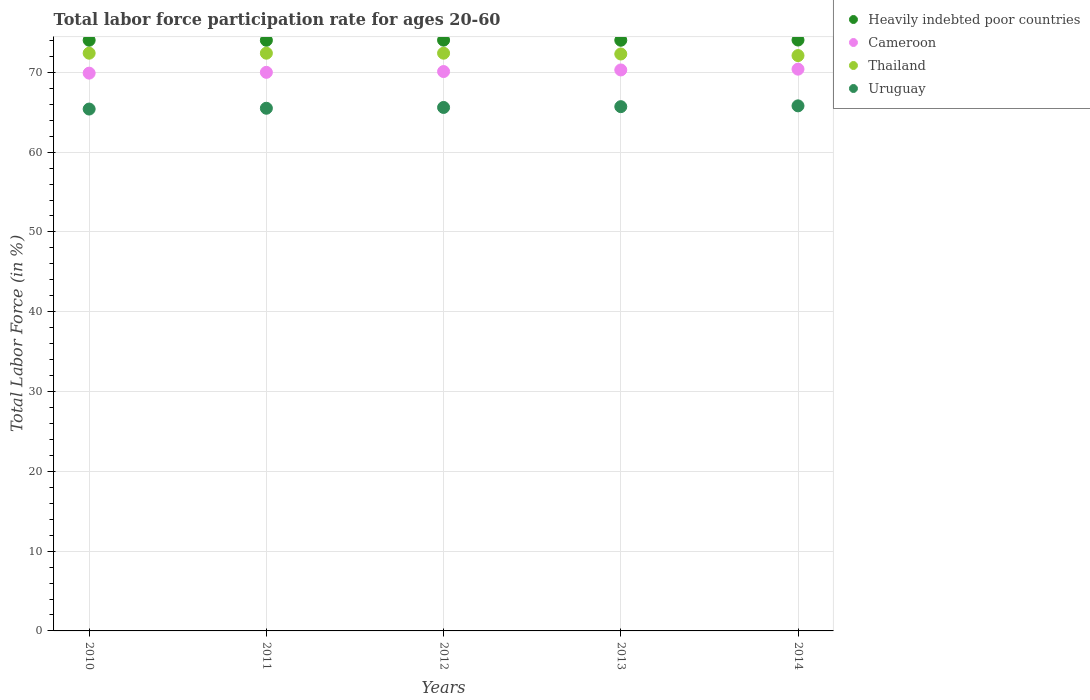How many different coloured dotlines are there?
Keep it short and to the point. 4. What is the labor force participation rate in Heavily indebted poor countries in 2012?
Your answer should be very brief. 74.03. Across all years, what is the maximum labor force participation rate in Uruguay?
Keep it short and to the point. 65.8. Across all years, what is the minimum labor force participation rate in Cameroon?
Give a very brief answer. 69.9. What is the total labor force participation rate in Uruguay in the graph?
Provide a short and direct response. 328. What is the difference between the labor force participation rate in Cameroon in 2011 and that in 2014?
Keep it short and to the point. -0.4. What is the difference between the labor force participation rate in Heavily indebted poor countries in 2013 and the labor force participation rate in Uruguay in 2014?
Provide a short and direct response. 8.22. What is the average labor force participation rate in Heavily indebted poor countries per year?
Offer a very short reply. 74.03. In the year 2010, what is the difference between the labor force participation rate in Uruguay and labor force participation rate in Cameroon?
Provide a succinct answer. -4.5. In how many years, is the labor force participation rate in Uruguay greater than 46 %?
Give a very brief answer. 5. What is the ratio of the labor force participation rate in Heavily indebted poor countries in 2010 to that in 2012?
Your response must be concise. 1. What is the difference between the highest and the second highest labor force participation rate in Uruguay?
Provide a succinct answer. 0.1. What is the difference between the highest and the lowest labor force participation rate in Cameroon?
Your answer should be very brief. 0.5. Is it the case that in every year, the sum of the labor force participation rate in Uruguay and labor force participation rate in Thailand  is greater than the labor force participation rate in Cameroon?
Provide a short and direct response. Yes. Does the labor force participation rate in Thailand monotonically increase over the years?
Your response must be concise. No. Does the graph contain any zero values?
Your answer should be very brief. No. Where does the legend appear in the graph?
Give a very brief answer. Top right. What is the title of the graph?
Make the answer very short. Total labor force participation rate for ages 20-60. Does "Micronesia" appear as one of the legend labels in the graph?
Offer a terse response. No. What is the Total Labor Force (in %) of Heavily indebted poor countries in 2010?
Keep it short and to the point. 74.02. What is the Total Labor Force (in %) in Cameroon in 2010?
Provide a short and direct response. 69.9. What is the Total Labor Force (in %) of Thailand in 2010?
Your response must be concise. 72.4. What is the Total Labor Force (in %) in Uruguay in 2010?
Your answer should be compact. 65.4. What is the Total Labor Force (in %) in Heavily indebted poor countries in 2011?
Your answer should be compact. 74.02. What is the Total Labor Force (in %) of Thailand in 2011?
Your answer should be compact. 72.4. What is the Total Labor Force (in %) in Uruguay in 2011?
Provide a short and direct response. 65.5. What is the Total Labor Force (in %) in Heavily indebted poor countries in 2012?
Make the answer very short. 74.03. What is the Total Labor Force (in %) of Cameroon in 2012?
Provide a short and direct response. 70.1. What is the Total Labor Force (in %) of Thailand in 2012?
Ensure brevity in your answer.  72.4. What is the Total Labor Force (in %) of Uruguay in 2012?
Make the answer very short. 65.6. What is the Total Labor Force (in %) in Heavily indebted poor countries in 2013?
Your answer should be very brief. 74.02. What is the Total Labor Force (in %) in Cameroon in 2013?
Keep it short and to the point. 70.3. What is the Total Labor Force (in %) in Thailand in 2013?
Make the answer very short. 72.3. What is the Total Labor Force (in %) in Uruguay in 2013?
Your answer should be very brief. 65.7. What is the Total Labor Force (in %) in Heavily indebted poor countries in 2014?
Provide a succinct answer. 74.05. What is the Total Labor Force (in %) in Cameroon in 2014?
Give a very brief answer. 70.4. What is the Total Labor Force (in %) of Thailand in 2014?
Your answer should be compact. 72.1. What is the Total Labor Force (in %) of Uruguay in 2014?
Provide a short and direct response. 65.8. Across all years, what is the maximum Total Labor Force (in %) in Heavily indebted poor countries?
Offer a terse response. 74.05. Across all years, what is the maximum Total Labor Force (in %) of Cameroon?
Offer a very short reply. 70.4. Across all years, what is the maximum Total Labor Force (in %) in Thailand?
Your answer should be compact. 72.4. Across all years, what is the maximum Total Labor Force (in %) in Uruguay?
Keep it short and to the point. 65.8. Across all years, what is the minimum Total Labor Force (in %) in Heavily indebted poor countries?
Keep it short and to the point. 74.02. Across all years, what is the minimum Total Labor Force (in %) in Cameroon?
Ensure brevity in your answer.  69.9. Across all years, what is the minimum Total Labor Force (in %) in Thailand?
Provide a succinct answer. 72.1. Across all years, what is the minimum Total Labor Force (in %) of Uruguay?
Provide a succinct answer. 65.4. What is the total Total Labor Force (in %) in Heavily indebted poor countries in the graph?
Make the answer very short. 370.15. What is the total Total Labor Force (in %) in Cameroon in the graph?
Offer a terse response. 350.7. What is the total Total Labor Force (in %) in Thailand in the graph?
Ensure brevity in your answer.  361.6. What is the total Total Labor Force (in %) of Uruguay in the graph?
Your answer should be compact. 328. What is the difference between the Total Labor Force (in %) in Heavily indebted poor countries in 2010 and that in 2011?
Provide a succinct answer. 0.01. What is the difference between the Total Labor Force (in %) in Thailand in 2010 and that in 2011?
Give a very brief answer. 0. What is the difference between the Total Labor Force (in %) of Uruguay in 2010 and that in 2011?
Your answer should be compact. -0.1. What is the difference between the Total Labor Force (in %) in Heavily indebted poor countries in 2010 and that in 2012?
Ensure brevity in your answer.  -0.01. What is the difference between the Total Labor Force (in %) of Cameroon in 2010 and that in 2012?
Your answer should be very brief. -0.2. What is the difference between the Total Labor Force (in %) of Thailand in 2010 and that in 2012?
Your answer should be compact. 0. What is the difference between the Total Labor Force (in %) in Heavily indebted poor countries in 2010 and that in 2013?
Make the answer very short. 0. What is the difference between the Total Labor Force (in %) in Thailand in 2010 and that in 2013?
Your response must be concise. 0.1. What is the difference between the Total Labor Force (in %) in Uruguay in 2010 and that in 2013?
Provide a succinct answer. -0.3. What is the difference between the Total Labor Force (in %) of Heavily indebted poor countries in 2010 and that in 2014?
Your answer should be very brief. -0.03. What is the difference between the Total Labor Force (in %) in Cameroon in 2010 and that in 2014?
Your answer should be compact. -0.5. What is the difference between the Total Labor Force (in %) of Thailand in 2010 and that in 2014?
Provide a succinct answer. 0.3. What is the difference between the Total Labor Force (in %) of Uruguay in 2010 and that in 2014?
Ensure brevity in your answer.  -0.4. What is the difference between the Total Labor Force (in %) of Heavily indebted poor countries in 2011 and that in 2012?
Provide a short and direct response. -0.02. What is the difference between the Total Labor Force (in %) of Thailand in 2011 and that in 2012?
Provide a short and direct response. 0. What is the difference between the Total Labor Force (in %) in Uruguay in 2011 and that in 2012?
Keep it short and to the point. -0.1. What is the difference between the Total Labor Force (in %) in Heavily indebted poor countries in 2011 and that in 2013?
Provide a short and direct response. -0. What is the difference between the Total Labor Force (in %) in Cameroon in 2011 and that in 2013?
Offer a terse response. -0.3. What is the difference between the Total Labor Force (in %) of Thailand in 2011 and that in 2013?
Offer a very short reply. 0.1. What is the difference between the Total Labor Force (in %) of Heavily indebted poor countries in 2011 and that in 2014?
Ensure brevity in your answer.  -0.03. What is the difference between the Total Labor Force (in %) in Cameroon in 2011 and that in 2014?
Ensure brevity in your answer.  -0.4. What is the difference between the Total Labor Force (in %) of Thailand in 2011 and that in 2014?
Provide a succinct answer. 0.3. What is the difference between the Total Labor Force (in %) in Uruguay in 2011 and that in 2014?
Your answer should be compact. -0.3. What is the difference between the Total Labor Force (in %) of Heavily indebted poor countries in 2012 and that in 2013?
Keep it short and to the point. 0.01. What is the difference between the Total Labor Force (in %) of Heavily indebted poor countries in 2012 and that in 2014?
Give a very brief answer. -0.02. What is the difference between the Total Labor Force (in %) of Cameroon in 2012 and that in 2014?
Ensure brevity in your answer.  -0.3. What is the difference between the Total Labor Force (in %) of Heavily indebted poor countries in 2013 and that in 2014?
Offer a very short reply. -0.03. What is the difference between the Total Labor Force (in %) of Cameroon in 2013 and that in 2014?
Your response must be concise. -0.1. What is the difference between the Total Labor Force (in %) in Thailand in 2013 and that in 2014?
Give a very brief answer. 0.2. What is the difference between the Total Labor Force (in %) of Heavily indebted poor countries in 2010 and the Total Labor Force (in %) of Cameroon in 2011?
Offer a very short reply. 4.02. What is the difference between the Total Labor Force (in %) of Heavily indebted poor countries in 2010 and the Total Labor Force (in %) of Thailand in 2011?
Offer a terse response. 1.62. What is the difference between the Total Labor Force (in %) of Heavily indebted poor countries in 2010 and the Total Labor Force (in %) of Uruguay in 2011?
Ensure brevity in your answer.  8.52. What is the difference between the Total Labor Force (in %) in Cameroon in 2010 and the Total Labor Force (in %) in Thailand in 2011?
Make the answer very short. -2.5. What is the difference between the Total Labor Force (in %) of Cameroon in 2010 and the Total Labor Force (in %) of Uruguay in 2011?
Ensure brevity in your answer.  4.4. What is the difference between the Total Labor Force (in %) in Heavily indebted poor countries in 2010 and the Total Labor Force (in %) in Cameroon in 2012?
Offer a terse response. 3.92. What is the difference between the Total Labor Force (in %) of Heavily indebted poor countries in 2010 and the Total Labor Force (in %) of Thailand in 2012?
Provide a succinct answer. 1.62. What is the difference between the Total Labor Force (in %) in Heavily indebted poor countries in 2010 and the Total Labor Force (in %) in Uruguay in 2012?
Offer a terse response. 8.42. What is the difference between the Total Labor Force (in %) of Cameroon in 2010 and the Total Labor Force (in %) of Thailand in 2012?
Make the answer very short. -2.5. What is the difference between the Total Labor Force (in %) in Thailand in 2010 and the Total Labor Force (in %) in Uruguay in 2012?
Give a very brief answer. 6.8. What is the difference between the Total Labor Force (in %) in Heavily indebted poor countries in 2010 and the Total Labor Force (in %) in Cameroon in 2013?
Your response must be concise. 3.72. What is the difference between the Total Labor Force (in %) in Heavily indebted poor countries in 2010 and the Total Labor Force (in %) in Thailand in 2013?
Offer a very short reply. 1.72. What is the difference between the Total Labor Force (in %) of Heavily indebted poor countries in 2010 and the Total Labor Force (in %) of Uruguay in 2013?
Keep it short and to the point. 8.32. What is the difference between the Total Labor Force (in %) of Cameroon in 2010 and the Total Labor Force (in %) of Thailand in 2013?
Your response must be concise. -2.4. What is the difference between the Total Labor Force (in %) of Cameroon in 2010 and the Total Labor Force (in %) of Uruguay in 2013?
Provide a short and direct response. 4.2. What is the difference between the Total Labor Force (in %) in Thailand in 2010 and the Total Labor Force (in %) in Uruguay in 2013?
Your answer should be very brief. 6.7. What is the difference between the Total Labor Force (in %) of Heavily indebted poor countries in 2010 and the Total Labor Force (in %) of Cameroon in 2014?
Keep it short and to the point. 3.62. What is the difference between the Total Labor Force (in %) in Heavily indebted poor countries in 2010 and the Total Labor Force (in %) in Thailand in 2014?
Offer a very short reply. 1.92. What is the difference between the Total Labor Force (in %) of Heavily indebted poor countries in 2010 and the Total Labor Force (in %) of Uruguay in 2014?
Your response must be concise. 8.22. What is the difference between the Total Labor Force (in %) in Thailand in 2010 and the Total Labor Force (in %) in Uruguay in 2014?
Your answer should be very brief. 6.6. What is the difference between the Total Labor Force (in %) in Heavily indebted poor countries in 2011 and the Total Labor Force (in %) in Cameroon in 2012?
Keep it short and to the point. 3.92. What is the difference between the Total Labor Force (in %) of Heavily indebted poor countries in 2011 and the Total Labor Force (in %) of Thailand in 2012?
Make the answer very short. 1.62. What is the difference between the Total Labor Force (in %) of Heavily indebted poor countries in 2011 and the Total Labor Force (in %) of Uruguay in 2012?
Provide a succinct answer. 8.42. What is the difference between the Total Labor Force (in %) of Cameroon in 2011 and the Total Labor Force (in %) of Thailand in 2012?
Offer a terse response. -2.4. What is the difference between the Total Labor Force (in %) in Cameroon in 2011 and the Total Labor Force (in %) in Uruguay in 2012?
Give a very brief answer. 4.4. What is the difference between the Total Labor Force (in %) of Thailand in 2011 and the Total Labor Force (in %) of Uruguay in 2012?
Provide a succinct answer. 6.8. What is the difference between the Total Labor Force (in %) of Heavily indebted poor countries in 2011 and the Total Labor Force (in %) of Cameroon in 2013?
Ensure brevity in your answer.  3.72. What is the difference between the Total Labor Force (in %) of Heavily indebted poor countries in 2011 and the Total Labor Force (in %) of Thailand in 2013?
Offer a terse response. 1.72. What is the difference between the Total Labor Force (in %) in Heavily indebted poor countries in 2011 and the Total Labor Force (in %) in Uruguay in 2013?
Give a very brief answer. 8.32. What is the difference between the Total Labor Force (in %) in Thailand in 2011 and the Total Labor Force (in %) in Uruguay in 2013?
Provide a short and direct response. 6.7. What is the difference between the Total Labor Force (in %) in Heavily indebted poor countries in 2011 and the Total Labor Force (in %) in Cameroon in 2014?
Your answer should be very brief. 3.62. What is the difference between the Total Labor Force (in %) in Heavily indebted poor countries in 2011 and the Total Labor Force (in %) in Thailand in 2014?
Make the answer very short. 1.92. What is the difference between the Total Labor Force (in %) in Heavily indebted poor countries in 2011 and the Total Labor Force (in %) in Uruguay in 2014?
Your answer should be very brief. 8.22. What is the difference between the Total Labor Force (in %) in Cameroon in 2011 and the Total Labor Force (in %) in Thailand in 2014?
Provide a short and direct response. -2.1. What is the difference between the Total Labor Force (in %) of Cameroon in 2011 and the Total Labor Force (in %) of Uruguay in 2014?
Make the answer very short. 4.2. What is the difference between the Total Labor Force (in %) in Thailand in 2011 and the Total Labor Force (in %) in Uruguay in 2014?
Make the answer very short. 6.6. What is the difference between the Total Labor Force (in %) in Heavily indebted poor countries in 2012 and the Total Labor Force (in %) in Cameroon in 2013?
Provide a short and direct response. 3.73. What is the difference between the Total Labor Force (in %) of Heavily indebted poor countries in 2012 and the Total Labor Force (in %) of Thailand in 2013?
Offer a very short reply. 1.73. What is the difference between the Total Labor Force (in %) in Heavily indebted poor countries in 2012 and the Total Labor Force (in %) in Uruguay in 2013?
Keep it short and to the point. 8.33. What is the difference between the Total Labor Force (in %) in Heavily indebted poor countries in 2012 and the Total Labor Force (in %) in Cameroon in 2014?
Ensure brevity in your answer.  3.63. What is the difference between the Total Labor Force (in %) of Heavily indebted poor countries in 2012 and the Total Labor Force (in %) of Thailand in 2014?
Offer a very short reply. 1.93. What is the difference between the Total Labor Force (in %) in Heavily indebted poor countries in 2012 and the Total Labor Force (in %) in Uruguay in 2014?
Provide a short and direct response. 8.23. What is the difference between the Total Labor Force (in %) in Thailand in 2012 and the Total Labor Force (in %) in Uruguay in 2014?
Ensure brevity in your answer.  6.6. What is the difference between the Total Labor Force (in %) of Heavily indebted poor countries in 2013 and the Total Labor Force (in %) of Cameroon in 2014?
Offer a very short reply. 3.62. What is the difference between the Total Labor Force (in %) in Heavily indebted poor countries in 2013 and the Total Labor Force (in %) in Thailand in 2014?
Your response must be concise. 1.92. What is the difference between the Total Labor Force (in %) of Heavily indebted poor countries in 2013 and the Total Labor Force (in %) of Uruguay in 2014?
Your response must be concise. 8.22. What is the difference between the Total Labor Force (in %) of Cameroon in 2013 and the Total Labor Force (in %) of Thailand in 2014?
Your answer should be compact. -1.8. What is the difference between the Total Labor Force (in %) of Thailand in 2013 and the Total Labor Force (in %) of Uruguay in 2014?
Offer a terse response. 6.5. What is the average Total Labor Force (in %) of Heavily indebted poor countries per year?
Keep it short and to the point. 74.03. What is the average Total Labor Force (in %) of Cameroon per year?
Make the answer very short. 70.14. What is the average Total Labor Force (in %) of Thailand per year?
Keep it short and to the point. 72.32. What is the average Total Labor Force (in %) in Uruguay per year?
Keep it short and to the point. 65.6. In the year 2010, what is the difference between the Total Labor Force (in %) in Heavily indebted poor countries and Total Labor Force (in %) in Cameroon?
Make the answer very short. 4.12. In the year 2010, what is the difference between the Total Labor Force (in %) of Heavily indebted poor countries and Total Labor Force (in %) of Thailand?
Offer a very short reply. 1.62. In the year 2010, what is the difference between the Total Labor Force (in %) in Heavily indebted poor countries and Total Labor Force (in %) in Uruguay?
Give a very brief answer. 8.62. In the year 2011, what is the difference between the Total Labor Force (in %) in Heavily indebted poor countries and Total Labor Force (in %) in Cameroon?
Ensure brevity in your answer.  4.02. In the year 2011, what is the difference between the Total Labor Force (in %) of Heavily indebted poor countries and Total Labor Force (in %) of Thailand?
Your answer should be very brief. 1.62. In the year 2011, what is the difference between the Total Labor Force (in %) in Heavily indebted poor countries and Total Labor Force (in %) in Uruguay?
Keep it short and to the point. 8.52. In the year 2011, what is the difference between the Total Labor Force (in %) in Cameroon and Total Labor Force (in %) in Thailand?
Your answer should be very brief. -2.4. In the year 2011, what is the difference between the Total Labor Force (in %) of Cameroon and Total Labor Force (in %) of Uruguay?
Make the answer very short. 4.5. In the year 2011, what is the difference between the Total Labor Force (in %) of Thailand and Total Labor Force (in %) of Uruguay?
Offer a very short reply. 6.9. In the year 2012, what is the difference between the Total Labor Force (in %) in Heavily indebted poor countries and Total Labor Force (in %) in Cameroon?
Offer a very short reply. 3.93. In the year 2012, what is the difference between the Total Labor Force (in %) in Heavily indebted poor countries and Total Labor Force (in %) in Thailand?
Offer a very short reply. 1.63. In the year 2012, what is the difference between the Total Labor Force (in %) in Heavily indebted poor countries and Total Labor Force (in %) in Uruguay?
Your answer should be very brief. 8.43. In the year 2013, what is the difference between the Total Labor Force (in %) in Heavily indebted poor countries and Total Labor Force (in %) in Cameroon?
Your answer should be very brief. 3.72. In the year 2013, what is the difference between the Total Labor Force (in %) in Heavily indebted poor countries and Total Labor Force (in %) in Thailand?
Offer a terse response. 1.72. In the year 2013, what is the difference between the Total Labor Force (in %) of Heavily indebted poor countries and Total Labor Force (in %) of Uruguay?
Offer a very short reply. 8.32. In the year 2013, what is the difference between the Total Labor Force (in %) of Cameroon and Total Labor Force (in %) of Thailand?
Keep it short and to the point. -2. In the year 2013, what is the difference between the Total Labor Force (in %) in Cameroon and Total Labor Force (in %) in Uruguay?
Provide a short and direct response. 4.6. In the year 2013, what is the difference between the Total Labor Force (in %) in Thailand and Total Labor Force (in %) in Uruguay?
Ensure brevity in your answer.  6.6. In the year 2014, what is the difference between the Total Labor Force (in %) in Heavily indebted poor countries and Total Labor Force (in %) in Cameroon?
Make the answer very short. 3.65. In the year 2014, what is the difference between the Total Labor Force (in %) in Heavily indebted poor countries and Total Labor Force (in %) in Thailand?
Make the answer very short. 1.95. In the year 2014, what is the difference between the Total Labor Force (in %) in Heavily indebted poor countries and Total Labor Force (in %) in Uruguay?
Your answer should be compact. 8.25. In the year 2014, what is the difference between the Total Labor Force (in %) of Cameroon and Total Labor Force (in %) of Thailand?
Make the answer very short. -1.7. In the year 2014, what is the difference between the Total Labor Force (in %) of Thailand and Total Labor Force (in %) of Uruguay?
Keep it short and to the point. 6.3. What is the ratio of the Total Labor Force (in %) of Heavily indebted poor countries in 2010 to that in 2011?
Offer a terse response. 1. What is the ratio of the Total Labor Force (in %) of Uruguay in 2010 to that in 2011?
Make the answer very short. 1. What is the ratio of the Total Labor Force (in %) of Heavily indebted poor countries in 2010 to that in 2012?
Your answer should be very brief. 1. What is the ratio of the Total Labor Force (in %) in Cameroon in 2010 to that in 2012?
Offer a very short reply. 1. What is the ratio of the Total Labor Force (in %) in Thailand in 2010 to that in 2012?
Keep it short and to the point. 1. What is the ratio of the Total Labor Force (in %) of Heavily indebted poor countries in 2010 to that in 2013?
Provide a succinct answer. 1. What is the ratio of the Total Labor Force (in %) of Cameroon in 2010 to that in 2013?
Your answer should be compact. 0.99. What is the ratio of the Total Labor Force (in %) of Uruguay in 2010 to that in 2014?
Offer a terse response. 0.99. What is the ratio of the Total Labor Force (in %) in Cameroon in 2011 to that in 2012?
Make the answer very short. 1. What is the ratio of the Total Labor Force (in %) in Heavily indebted poor countries in 2011 to that in 2013?
Give a very brief answer. 1. What is the ratio of the Total Labor Force (in %) in Uruguay in 2011 to that in 2013?
Offer a terse response. 1. What is the ratio of the Total Labor Force (in %) in Cameroon in 2011 to that in 2014?
Offer a very short reply. 0.99. What is the ratio of the Total Labor Force (in %) of Uruguay in 2011 to that in 2014?
Ensure brevity in your answer.  1. What is the ratio of the Total Labor Force (in %) of Cameroon in 2012 to that in 2013?
Your answer should be very brief. 1. What is the ratio of the Total Labor Force (in %) of Thailand in 2012 to that in 2013?
Keep it short and to the point. 1. What is the ratio of the Total Labor Force (in %) of Uruguay in 2012 to that in 2013?
Offer a very short reply. 1. What is the ratio of the Total Labor Force (in %) in Thailand in 2012 to that in 2014?
Make the answer very short. 1. What is the ratio of the Total Labor Force (in %) of Uruguay in 2012 to that in 2014?
Offer a very short reply. 1. What is the ratio of the Total Labor Force (in %) of Uruguay in 2013 to that in 2014?
Provide a short and direct response. 1. What is the difference between the highest and the second highest Total Labor Force (in %) in Heavily indebted poor countries?
Offer a very short reply. 0.02. What is the difference between the highest and the second highest Total Labor Force (in %) of Thailand?
Ensure brevity in your answer.  0. What is the difference between the highest and the lowest Total Labor Force (in %) in Heavily indebted poor countries?
Your answer should be compact. 0.03. What is the difference between the highest and the lowest Total Labor Force (in %) of Cameroon?
Your response must be concise. 0.5. What is the difference between the highest and the lowest Total Labor Force (in %) in Thailand?
Your response must be concise. 0.3. What is the difference between the highest and the lowest Total Labor Force (in %) in Uruguay?
Provide a short and direct response. 0.4. 